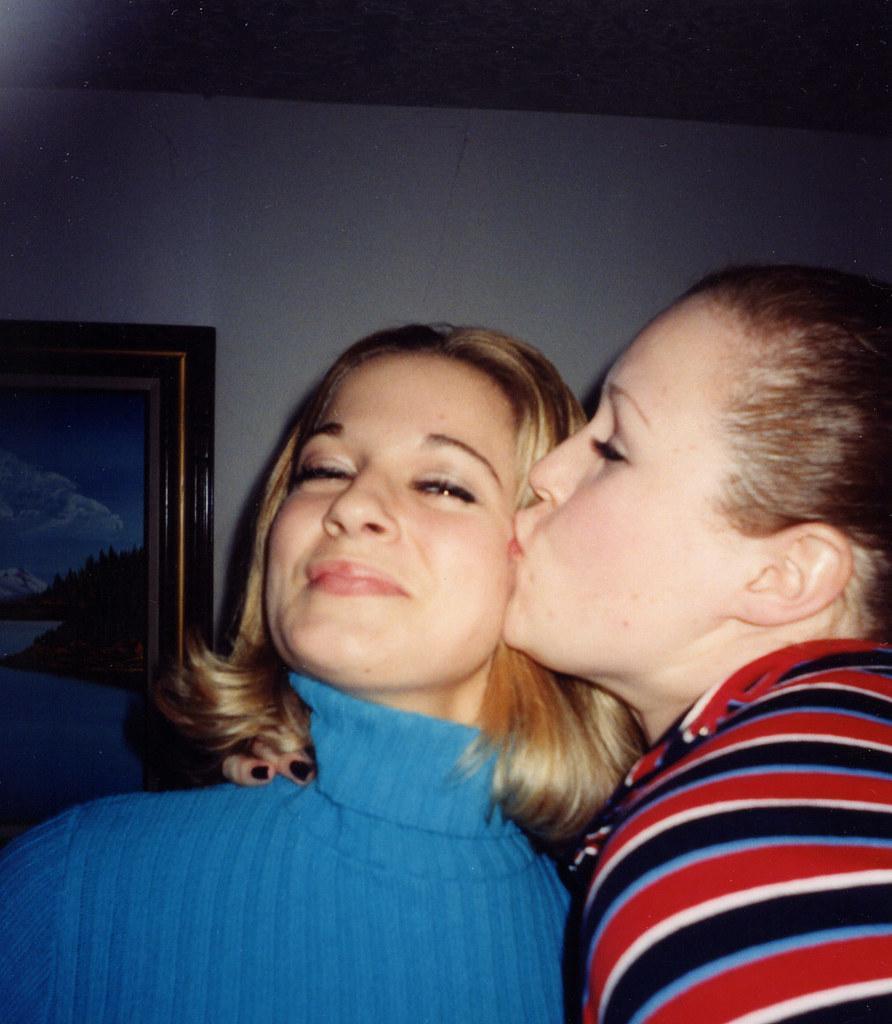Can you describe this image briefly? This image consists of two women. On the right, the woman is wearing a red dress. On the left, the woman is wearing a blue dress. In the background, we can see a frame on the wall. At the top, there is sky. 